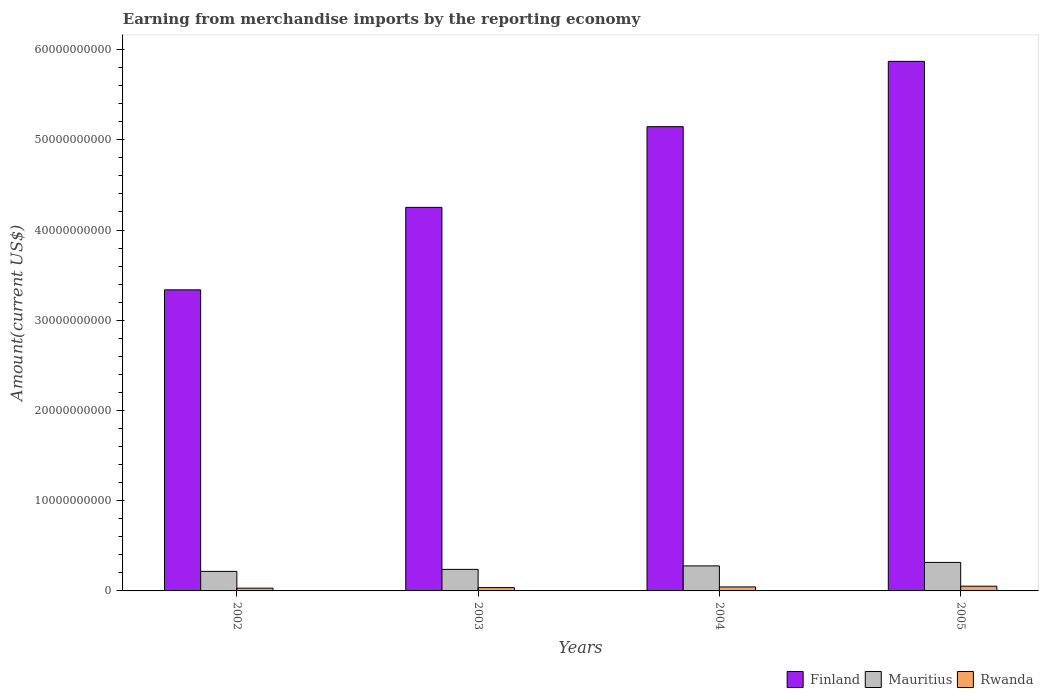How many different coloured bars are there?
Offer a terse response. 3. How many groups of bars are there?
Offer a very short reply. 4. How many bars are there on the 3rd tick from the right?
Your response must be concise. 3. In how many cases, is the number of bars for a given year not equal to the number of legend labels?
Make the answer very short. 0. What is the amount earned from merchandise imports in Rwanda in 2002?
Make the answer very short. 3.03e+08. Across all years, what is the maximum amount earned from merchandise imports in Rwanda?
Your response must be concise. 5.23e+08. Across all years, what is the minimum amount earned from merchandise imports in Rwanda?
Provide a short and direct response. 3.03e+08. In which year was the amount earned from merchandise imports in Finland minimum?
Your answer should be very brief. 2002. What is the total amount earned from merchandise imports in Mauritius in the graph?
Your response must be concise. 1.05e+1. What is the difference between the amount earned from merchandise imports in Mauritius in 2002 and that in 2005?
Offer a terse response. -9.96e+08. What is the difference between the amount earned from merchandise imports in Mauritius in 2005 and the amount earned from merchandise imports in Rwanda in 2002?
Offer a very short reply. 2.86e+09. What is the average amount earned from merchandise imports in Finland per year?
Provide a succinct answer. 4.65e+1. In the year 2005, what is the difference between the amount earned from merchandise imports in Finland and amount earned from merchandise imports in Rwanda?
Make the answer very short. 5.82e+1. In how many years, is the amount earned from merchandise imports in Finland greater than 2000000000 US$?
Your answer should be compact. 4. What is the ratio of the amount earned from merchandise imports in Rwanda in 2004 to that in 2005?
Your answer should be compact. 0.85. Is the difference between the amount earned from merchandise imports in Finland in 2002 and 2004 greater than the difference between the amount earned from merchandise imports in Rwanda in 2002 and 2004?
Your response must be concise. No. What is the difference between the highest and the second highest amount earned from merchandise imports in Mauritius?
Provide a succinct answer. 3.88e+08. What is the difference between the highest and the lowest amount earned from merchandise imports in Mauritius?
Keep it short and to the point. 9.96e+08. In how many years, is the amount earned from merchandise imports in Rwanda greater than the average amount earned from merchandise imports in Rwanda taken over all years?
Provide a succinct answer. 2. What does the 3rd bar from the left in 2004 represents?
Your answer should be very brief. Rwanda. What does the 2nd bar from the right in 2005 represents?
Ensure brevity in your answer.  Mauritius. Is it the case that in every year, the sum of the amount earned from merchandise imports in Mauritius and amount earned from merchandise imports in Rwanda is greater than the amount earned from merchandise imports in Finland?
Your response must be concise. No. Are all the bars in the graph horizontal?
Your answer should be very brief. No. How many years are there in the graph?
Your response must be concise. 4. What is the difference between two consecutive major ticks on the Y-axis?
Your response must be concise. 1.00e+1. Where does the legend appear in the graph?
Offer a terse response. Bottom right. How many legend labels are there?
Offer a very short reply. 3. What is the title of the graph?
Offer a terse response. Earning from merchandise imports by the reporting economy. Does "Barbados" appear as one of the legend labels in the graph?
Offer a very short reply. No. What is the label or title of the Y-axis?
Ensure brevity in your answer.  Amount(current US$). What is the Amount(current US$) of Finland in 2002?
Your answer should be compact. 3.34e+1. What is the Amount(current US$) of Mauritius in 2002?
Your response must be concise. 2.17e+09. What is the Amount(current US$) of Rwanda in 2002?
Offer a terse response. 3.03e+08. What is the Amount(current US$) in Finland in 2003?
Provide a short and direct response. 4.25e+1. What is the Amount(current US$) in Mauritius in 2003?
Provide a succinct answer. 2.39e+09. What is the Amount(current US$) of Rwanda in 2003?
Offer a terse response. 3.70e+08. What is the Amount(current US$) of Finland in 2004?
Make the answer very short. 5.15e+1. What is the Amount(current US$) in Mauritius in 2004?
Offer a terse response. 2.77e+09. What is the Amount(current US$) in Rwanda in 2004?
Offer a terse response. 4.43e+08. What is the Amount(current US$) of Finland in 2005?
Offer a very short reply. 5.87e+1. What is the Amount(current US$) of Mauritius in 2005?
Provide a short and direct response. 3.16e+09. What is the Amount(current US$) of Rwanda in 2005?
Your answer should be very brief. 5.23e+08. Across all years, what is the maximum Amount(current US$) of Finland?
Your response must be concise. 5.87e+1. Across all years, what is the maximum Amount(current US$) of Mauritius?
Give a very brief answer. 3.16e+09. Across all years, what is the maximum Amount(current US$) of Rwanda?
Your answer should be compact. 5.23e+08. Across all years, what is the minimum Amount(current US$) in Finland?
Offer a very short reply. 3.34e+1. Across all years, what is the minimum Amount(current US$) of Mauritius?
Ensure brevity in your answer.  2.17e+09. Across all years, what is the minimum Amount(current US$) of Rwanda?
Your answer should be compact. 3.03e+08. What is the total Amount(current US$) of Finland in the graph?
Keep it short and to the point. 1.86e+11. What is the total Amount(current US$) of Mauritius in the graph?
Offer a very short reply. 1.05e+1. What is the total Amount(current US$) in Rwanda in the graph?
Give a very brief answer. 1.64e+09. What is the difference between the Amount(current US$) of Finland in 2002 and that in 2003?
Your response must be concise. -9.14e+09. What is the difference between the Amount(current US$) in Mauritius in 2002 and that in 2003?
Offer a very short reply. -2.22e+08. What is the difference between the Amount(current US$) of Rwanda in 2002 and that in 2003?
Provide a succinct answer. -6.72e+07. What is the difference between the Amount(current US$) in Finland in 2002 and that in 2004?
Provide a succinct answer. -1.81e+1. What is the difference between the Amount(current US$) of Mauritius in 2002 and that in 2004?
Keep it short and to the point. -6.08e+08. What is the difference between the Amount(current US$) in Rwanda in 2002 and that in 2004?
Provide a succinct answer. -1.40e+08. What is the difference between the Amount(current US$) in Finland in 2002 and that in 2005?
Your answer should be compact. -2.53e+1. What is the difference between the Amount(current US$) of Mauritius in 2002 and that in 2005?
Ensure brevity in your answer.  -9.96e+08. What is the difference between the Amount(current US$) of Rwanda in 2002 and that in 2005?
Offer a terse response. -2.20e+08. What is the difference between the Amount(current US$) of Finland in 2003 and that in 2004?
Your answer should be compact. -8.94e+09. What is the difference between the Amount(current US$) in Mauritius in 2003 and that in 2004?
Provide a short and direct response. -3.86e+08. What is the difference between the Amount(current US$) in Rwanda in 2003 and that in 2004?
Keep it short and to the point. -7.31e+07. What is the difference between the Amount(current US$) of Finland in 2003 and that in 2005?
Your answer should be very brief. -1.62e+1. What is the difference between the Amount(current US$) in Mauritius in 2003 and that in 2005?
Offer a terse response. -7.74e+08. What is the difference between the Amount(current US$) of Rwanda in 2003 and that in 2005?
Provide a succinct answer. -1.53e+08. What is the difference between the Amount(current US$) of Finland in 2004 and that in 2005?
Provide a succinct answer. -7.24e+09. What is the difference between the Amount(current US$) in Mauritius in 2004 and that in 2005?
Make the answer very short. -3.88e+08. What is the difference between the Amount(current US$) in Rwanda in 2004 and that in 2005?
Your answer should be very brief. -7.99e+07. What is the difference between the Amount(current US$) of Finland in 2002 and the Amount(current US$) of Mauritius in 2003?
Give a very brief answer. 3.10e+1. What is the difference between the Amount(current US$) of Finland in 2002 and the Amount(current US$) of Rwanda in 2003?
Provide a succinct answer. 3.30e+1. What is the difference between the Amount(current US$) of Mauritius in 2002 and the Amount(current US$) of Rwanda in 2003?
Your answer should be very brief. 1.80e+09. What is the difference between the Amount(current US$) of Finland in 2002 and the Amount(current US$) of Mauritius in 2004?
Give a very brief answer. 3.06e+1. What is the difference between the Amount(current US$) of Finland in 2002 and the Amount(current US$) of Rwanda in 2004?
Your answer should be compact. 3.29e+1. What is the difference between the Amount(current US$) in Mauritius in 2002 and the Amount(current US$) in Rwanda in 2004?
Keep it short and to the point. 1.72e+09. What is the difference between the Amount(current US$) of Finland in 2002 and the Amount(current US$) of Mauritius in 2005?
Provide a succinct answer. 3.02e+1. What is the difference between the Amount(current US$) in Finland in 2002 and the Amount(current US$) in Rwanda in 2005?
Provide a short and direct response. 3.28e+1. What is the difference between the Amount(current US$) of Mauritius in 2002 and the Amount(current US$) of Rwanda in 2005?
Make the answer very short. 1.64e+09. What is the difference between the Amount(current US$) of Finland in 2003 and the Amount(current US$) of Mauritius in 2004?
Provide a succinct answer. 3.97e+1. What is the difference between the Amount(current US$) of Finland in 2003 and the Amount(current US$) of Rwanda in 2004?
Your response must be concise. 4.21e+1. What is the difference between the Amount(current US$) in Mauritius in 2003 and the Amount(current US$) in Rwanda in 2004?
Give a very brief answer. 1.94e+09. What is the difference between the Amount(current US$) of Finland in 2003 and the Amount(current US$) of Mauritius in 2005?
Your response must be concise. 3.93e+1. What is the difference between the Amount(current US$) of Finland in 2003 and the Amount(current US$) of Rwanda in 2005?
Your answer should be compact. 4.20e+1. What is the difference between the Amount(current US$) in Mauritius in 2003 and the Amount(current US$) in Rwanda in 2005?
Your answer should be compact. 1.86e+09. What is the difference between the Amount(current US$) in Finland in 2004 and the Amount(current US$) in Mauritius in 2005?
Keep it short and to the point. 4.83e+1. What is the difference between the Amount(current US$) in Finland in 2004 and the Amount(current US$) in Rwanda in 2005?
Your answer should be compact. 5.09e+1. What is the difference between the Amount(current US$) in Mauritius in 2004 and the Amount(current US$) in Rwanda in 2005?
Keep it short and to the point. 2.25e+09. What is the average Amount(current US$) in Finland per year?
Offer a very short reply. 4.65e+1. What is the average Amount(current US$) of Mauritius per year?
Provide a succinct answer. 2.62e+09. What is the average Amount(current US$) in Rwanda per year?
Ensure brevity in your answer.  4.10e+08. In the year 2002, what is the difference between the Amount(current US$) of Finland and Amount(current US$) of Mauritius?
Provide a succinct answer. 3.12e+1. In the year 2002, what is the difference between the Amount(current US$) of Finland and Amount(current US$) of Rwanda?
Give a very brief answer. 3.31e+1. In the year 2002, what is the difference between the Amount(current US$) of Mauritius and Amount(current US$) of Rwanda?
Provide a short and direct response. 1.86e+09. In the year 2003, what is the difference between the Amount(current US$) in Finland and Amount(current US$) in Mauritius?
Your response must be concise. 4.01e+1. In the year 2003, what is the difference between the Amount(current US$) of Finland and Amount(current US$) of Rwanda?
Ensure brevity in your answer.  4.21e+1. In the year 2003, what is the difference between the Amount(current US$) of Mauritius and Amount(current US$) of Rwanda?
Ensure brevity in your answer.  2.02e+09. In the year 2004, what is the difference between the Amount(current US$) of Finland and Amount(current US$) of Mauritius?
Offer a very short reply. 4.87e+1. In the year 2004, what is the difference between the Amount(current US$) in Finland and Amount(current US$) in Rwanda?
Your response must be concise. 5.10e+1. In the year 2004, what is the difference between the Amount(current US$) of Mauritius and Amount(current US$) of Rwanda?
Ensure brevity in your answer.  2.33e+09. In the year 2005, what is the difference between the Amount(current US$) of Finland and Amount(current US$) of Mauritius?
Offer a terse response. 5.55e+1. In the year 2005, what is the difference between the Amount(current US$) in Finland and Amount(current US$) in Rwanda?
Offer a very short reply. 5.82e+1. In the year 2005, what is the difference between the Amount(current US$) in Mauritius and Amount(current US$) in Rwanda?
Provide a short and direct response. 2.64e+09. What is the ratio of the Amount(current US$) in Finland in 2002 to that in 2003?
Ensure brevity in your answer.  0.79. What is the ratio of the Amount(current US$) in Mauritius in 2002 to that in 2003?
Keep it short and to the point. 0.91. What is the ratio of the Amount(current US$) of Rwanda in 2002 to that in 2003?
Provide a short and direct response. 0.82. What is the ratio of the Amount(current US$) of Finland in 2002 to that in 2004?
Provide a succinct answer. 0.65. What is the ratio of the Amount(current US$) of Mauritius in 2002 to that in 2004?
Offer a very short reply. 0.78. What is the ratio of the Amount(current US$) of Rwanda in 2002 to that in 2004?
Make the answer very short. 0.68. What is the ratio of the Amount(current US$) in Finland in 2002 to that in 2005?
Provide a short and direct response. 0.57. What is the ratio of the Amount(current US$) in Mauritius in 2002 to that in 2005?
Make the answer very short. 0.69. What is the ratio of the Amount(current US$) in Rwanda in 2002 to that in 2005?
Your answer should be compact. 0.58. What is the ratio of the Amount(current US$) in Finland in 2003 to that in 2004?
Your response must be concise. 0.83. What is the ratio of the Amount(current US$) of Mauritius in 2003 to that in 2004?
Offer a terse response. 0.86. What is the ratio of the Amount(current US$) of Rwanda in 2003 to that in 2004?
Keep it short and to the point. 0.84. What is the ratio of the Amount(current US$) of Finland in 2003 to that in 2005?
Provide a short and direct response. 0.72. What is the ratio of the Amount(current US$) of Mauritius in 2003 to that in 2005?
Make the answer very short. 0.76. What is the ratio of the Amount(current US$) of Rwanda in 2003 to that in 2005?
Offer a very short reply. 0.71. What is the ratio of the Amount(current US$) in Finland in 2004 to that in 2005?
Offer a very short reply. 0.88. What is the ratio of the Amount(current US$) of Mauritius in 2004 to that in 2005?
Ensure brevity in your answer.  0.88. What is the ratio of the Amount(current US$) of Rwanda in 2004 to that in 2005?
Give a very brief answer. 0.85. What is the difference between the highest and the second highest Amount(current US$) in Finland?
Ensure brevity in your answer.  7.24e+09. What is the difference between the highest and the second highest Amount(current US$) of Mauritius?
Give a very brief answer. 3.88e+08. What is the difference between the highest and the second highest Amount(current US$) of Rwanda?
Your answer should be compact. 7.99e+07. What is the difference between the highest and the lowest Amount(current US$) of Finland?
Provide a succinct answer. 2.53e+1. What is the difference between the highest and the lowest Amount(current US$) in Mauritius?
Offer a terse response. 9.96e+08. What is the difference between the highest and the lowest Amount(current US$) of Rwanda?
Your answer should be very brief. 2.20e+08. 